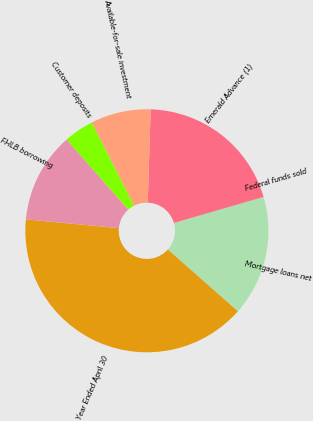Convert chart. <chart><loc_0><loc_0><loc_500><loc_500><pie_chart><fcel>Year Ended April 30<fcel>Mortgage loans net<fcel>Federal funds sold<fcel>Emerald Advance (1)<fcel>Available-for-sale investment<fcel>Customer deposits<fcel>FHLB borrowing<nl><fcel>39.99%<fcel>16.0%<fcel>0.01%<fcel>20.0%<fcel>8.0%<fcel>4.0%<fcel>12.0%<nl></chart> 